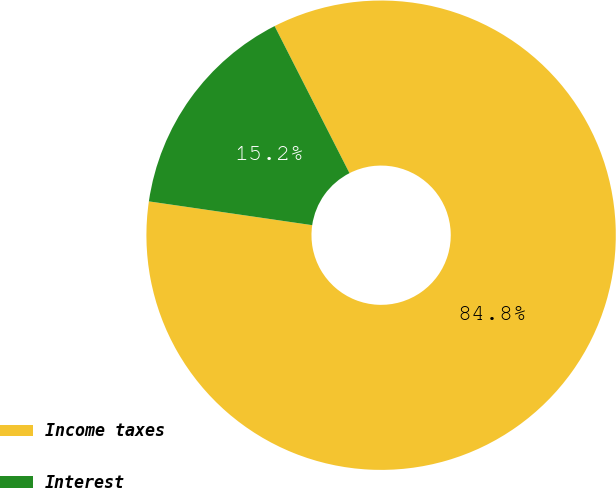Convert chart to OTSL. <chart><loc_0><loc_0><loc_500><loc_500><pie_chart><fcel>Income taxes<fcel>Interest<nl><fcel>84.8%<fcel>15.2%<nl></chart> 